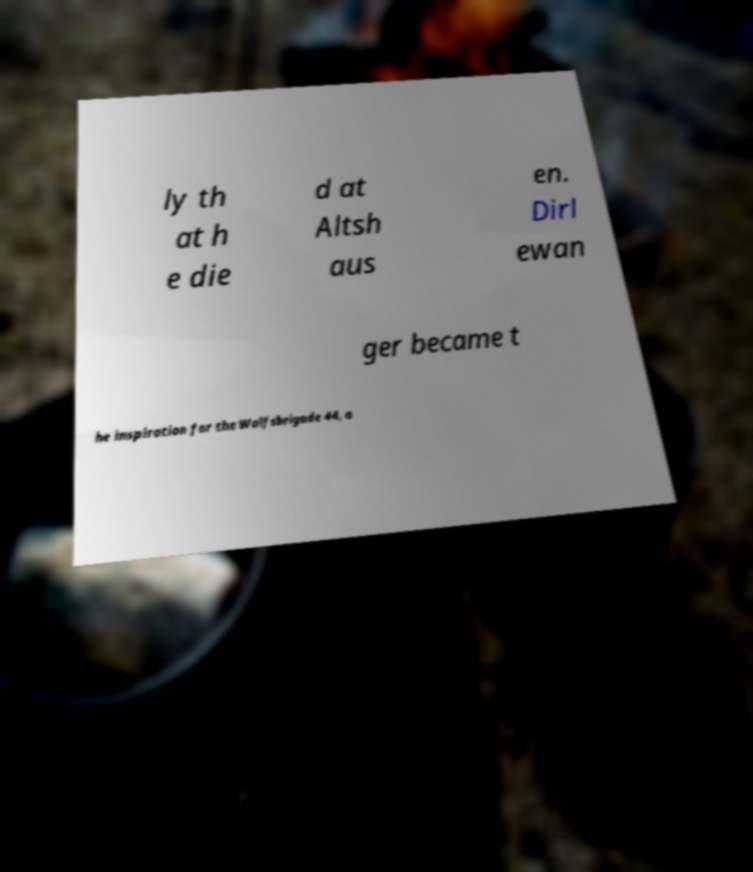Could you assist in decoding the text presented in this image and type it out clearly? ly th at h e die d at Altsh aus en. Dirl ewan ger became t he inspiration for the Wolfsbrigade 44, a 